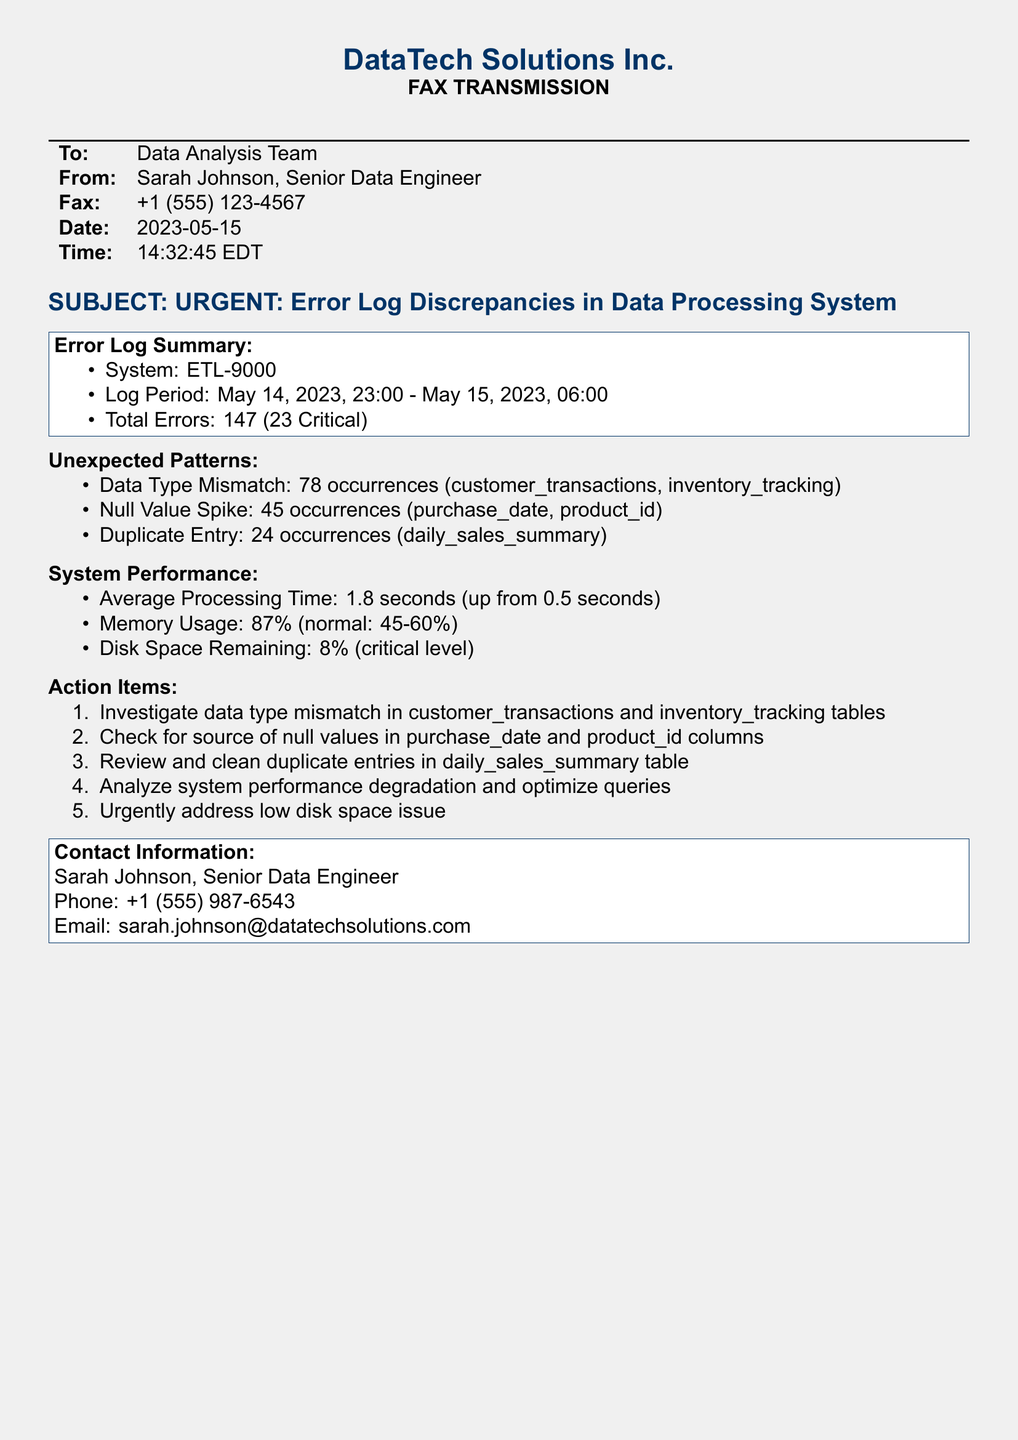what is the total number of errors reported? The document states that there were a total of 147 errors recorded in the error log.
Answer: 147 how many critical errors are mentioned? The error log summary specifies that there are 23 critical errors among the total errors.
Answer: 23 what is the average processing time reported? The document indicates an average processing time of 1.8 seconds, which is a notable increase from the previous time.
Answer: 1.8 seconds which two data columns experienced a null value spike? The unexpected patterns section lists purchase_date and product_id as the columns with a spike in null values.
Answer: purchase_date, product_id what is the current memory usage percentage? The document indicates that the current memory usage is at 87%, which exceeds the normal range of 45-60%.
Answer: 87% what action item addresses the low disk space issue? The action items include an urgent directive to address the low disk space issue.
Answer: Urgently address low disk space issue who is the sender of this fax? The document lists Sarah Johnson as the sender, who is a Senior Data Engineer.
Answer: Sarah Johnson what time was the fax sent? The fax indicates that it was sent at 14:32:45 EDT on May 15, 2023.
Answer: 14:32:45 EDT how many occurrences of duplicate entries were recorded? The unexpected patterns section mentions a total of 24 occurrences related to duplicate entries.
Answer: 24 